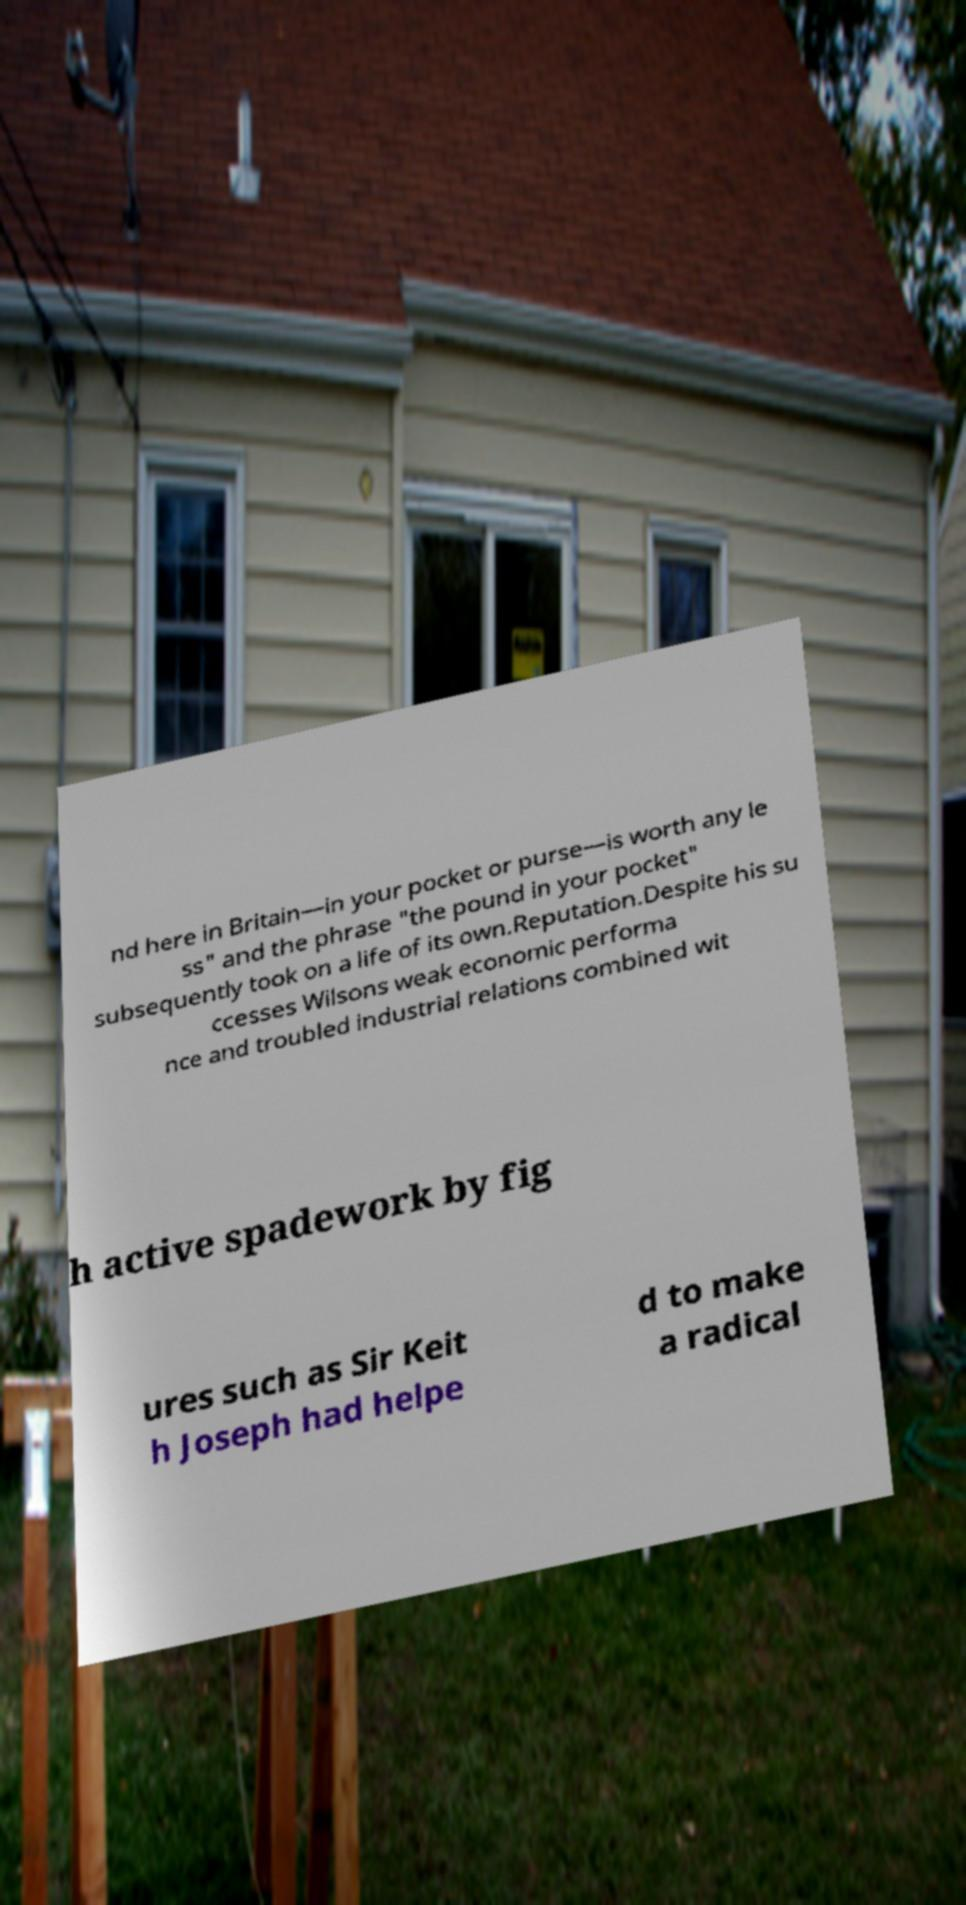There's text embedded in this image that I need extracted. Can you transcribe it verbatim? nd here in Britain—in your pocket or purse—is worth any le ss" and the phrase "the pound in your pocket" subsequently took on a life of its own.Reputation.Despite his su ccesses Wilsons weak economic performa nce and troubled industrial relations combined wit h active spadework by fig ures such as Sir Keit h Joseph had helpe d to make a radical 